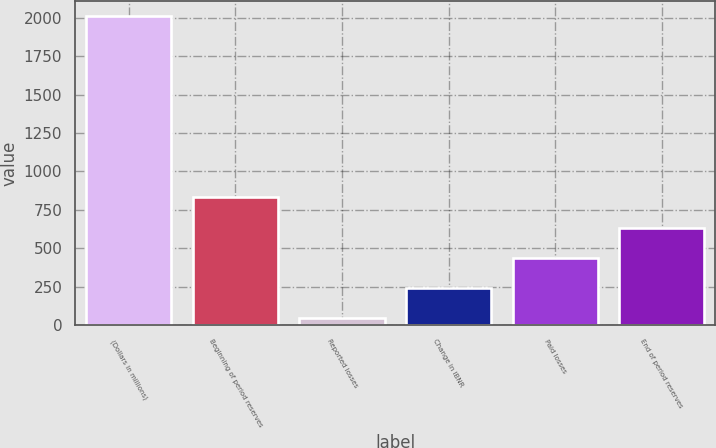<chart> <loc_0><loc_0><loc_500><loc_500><bar_chart><fcel>(Dollars in millions)<fcel>Beginning of period reserves<fcel>Reported losses<fcel>Change in IBNR<fcel>Paid losses<fcel>End of period reserves<nl><fcel>2009<fcel>830.84<fcel>45.4<fcel>241.76<fcel>438.12<fcel>634.48<nl></chart> 